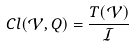Convert formula to latex. <formula><loc_0><loc_0><loc_500><loc_500>C l ( \mathcal { V } , Q ) = \frac { T ( \mathcal { V } ) } { \mathcal { I } }</formula> 